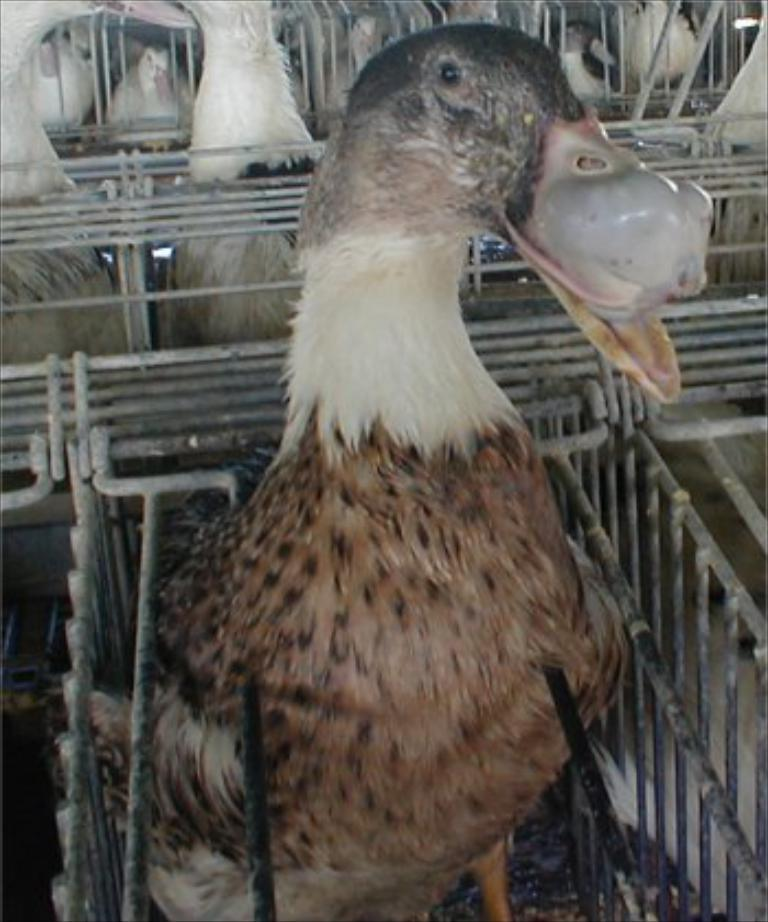What type of animal is in the steel tray in the image? There is a duck in a steel tray in the image. Can you describe the setting where the ducks are located? There are many ducks in a cage in the image. What type of wilderness can be seen in the background of the image? There is no wilderness visible in the image; it features a duck in a steel tray and many ducks in a cage. Can you describe the ball that is being used by the ducks in the image? There is no ball present in the image; it only features ducks in a cage and a duck in a steel tray. 